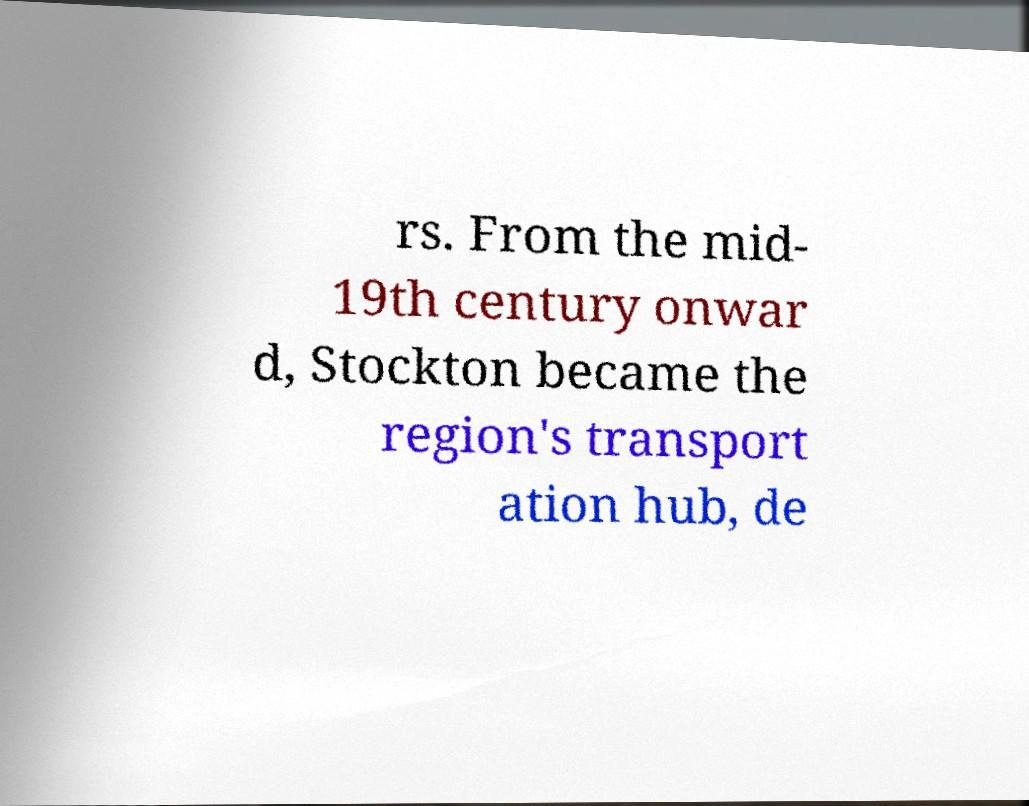There's text embedded in this image that I need extracted. Can you transcribe it verbatim? rs. From the mid- 19th century onwar d, Stockton became the region's transport ation hub, de 